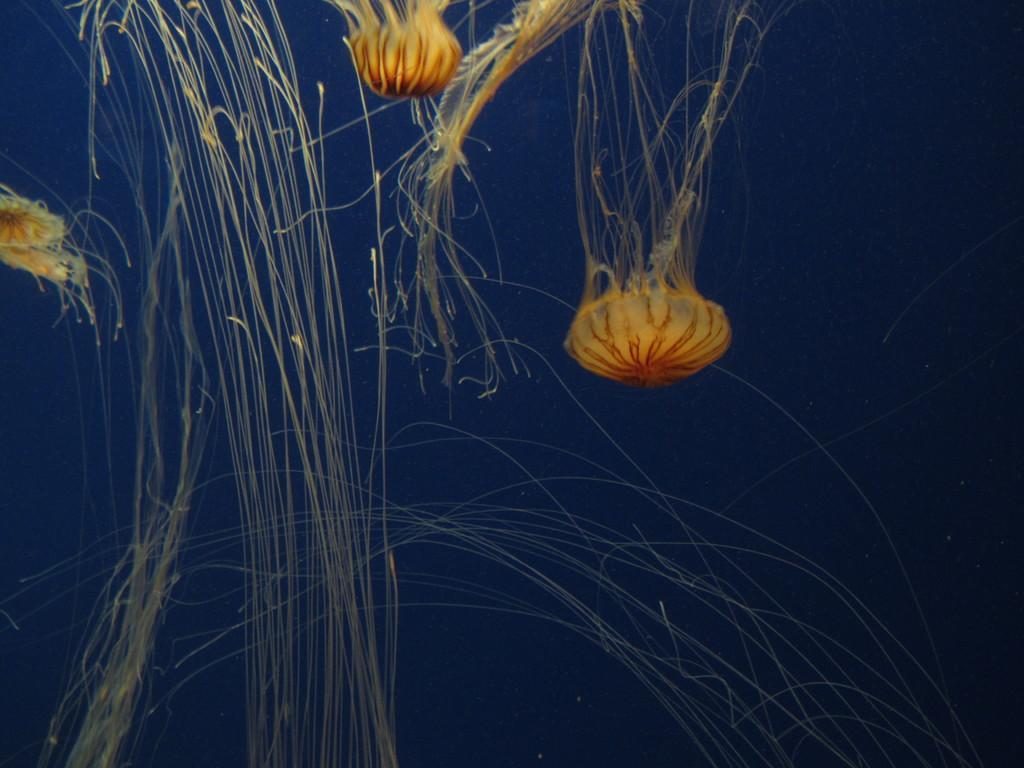Could you give a brief overview of what you see in this image? Here we can see there jellyfishes in the water. 